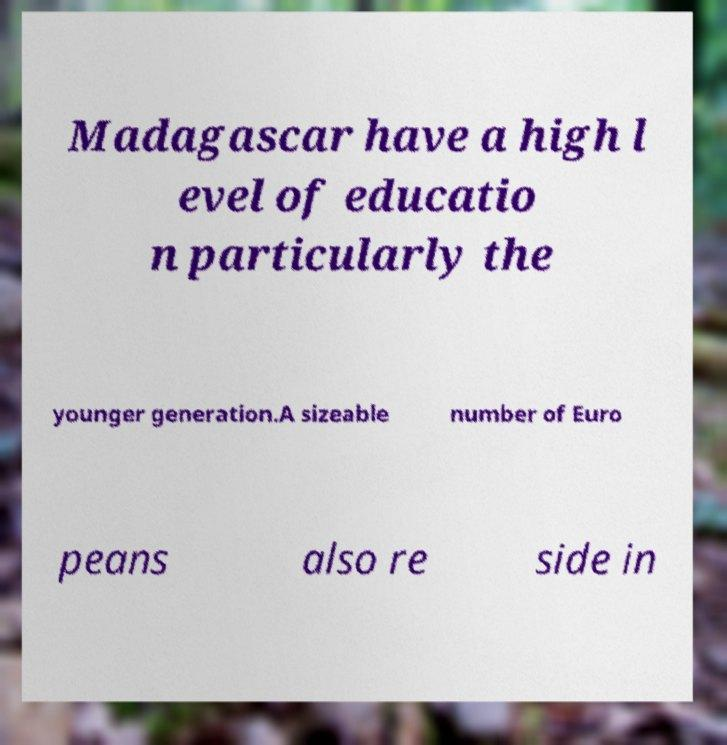What messages or text are displayed in this image? I need them in a readable, typed format. Madagascar have a high l evel of educatio n particularly the younger generation.A sizeable number of Euro peans also re side in 